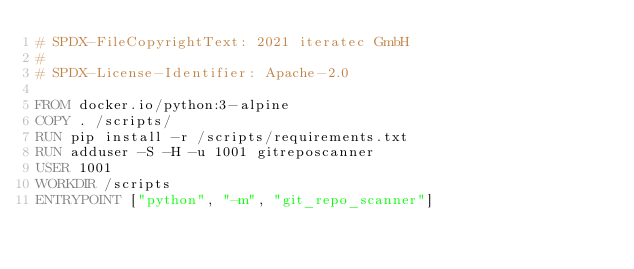<code> <loc_0><loc_0><loc_500><loc_500><_Dockerfile_># SPDX-FileCopyrightText: 2021 iteratec GmbH
#
# SPDX-License-Identifier: Apache-2.0

FROM docker.io/python:3-alpine
COPY . /scripts/
RUN pip install -r /scripts/requirements.txt
RUN adduser -S -H -u 1001 gitreposcanner
USER 1001
WORKDIR /scripts
ENTRYPOINT ["python", "-m", "git_repo_scanner"]
</code> 